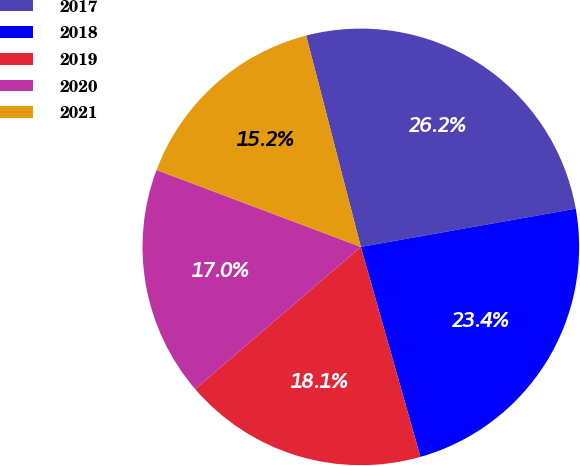Convert chart to OTSL. <chart><loc_0><loc_0><loc_500><loc_500><pie_chart><fcel>2017<fcel>2018<fcel>2019<fcel>2020<fcel>2021<nl><fcel>26.23%<fcel>23.4%<fcel>18.11%<fcel>17.02%<fcel>15.24%<nl></chart> 